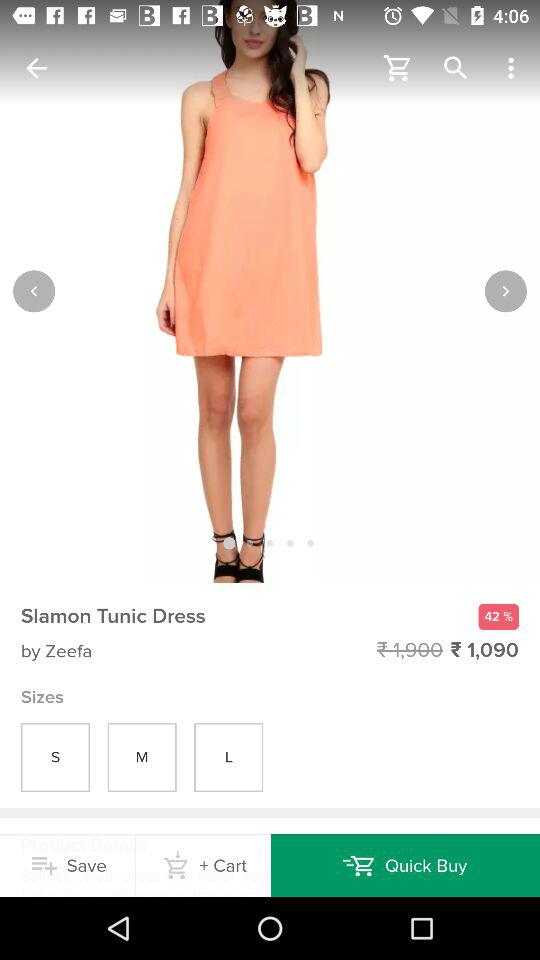What's the discounted price of the dress? The discounted price of the dress is ₹1,090. 